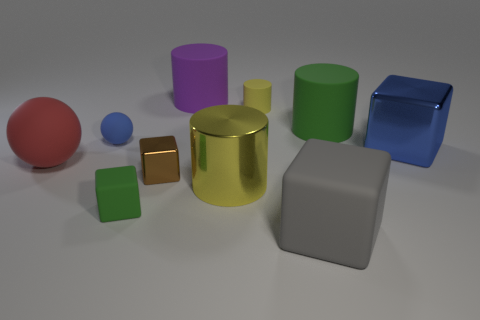Subtract 1 cubes. How many cubes are left? 3 Subtract all balls. How many objects are left? 8 Subtract 0 blue cylinders. How many objects are left? 10 Subtract all blue things. Subtract all blue shiny blocks. How many objects are left? 7 Add 2 blue metallic cubes. How many blue metallic cubes are left? 3 Add 5 purple matte cylinders. How many purple matte cylinders exist? 6 